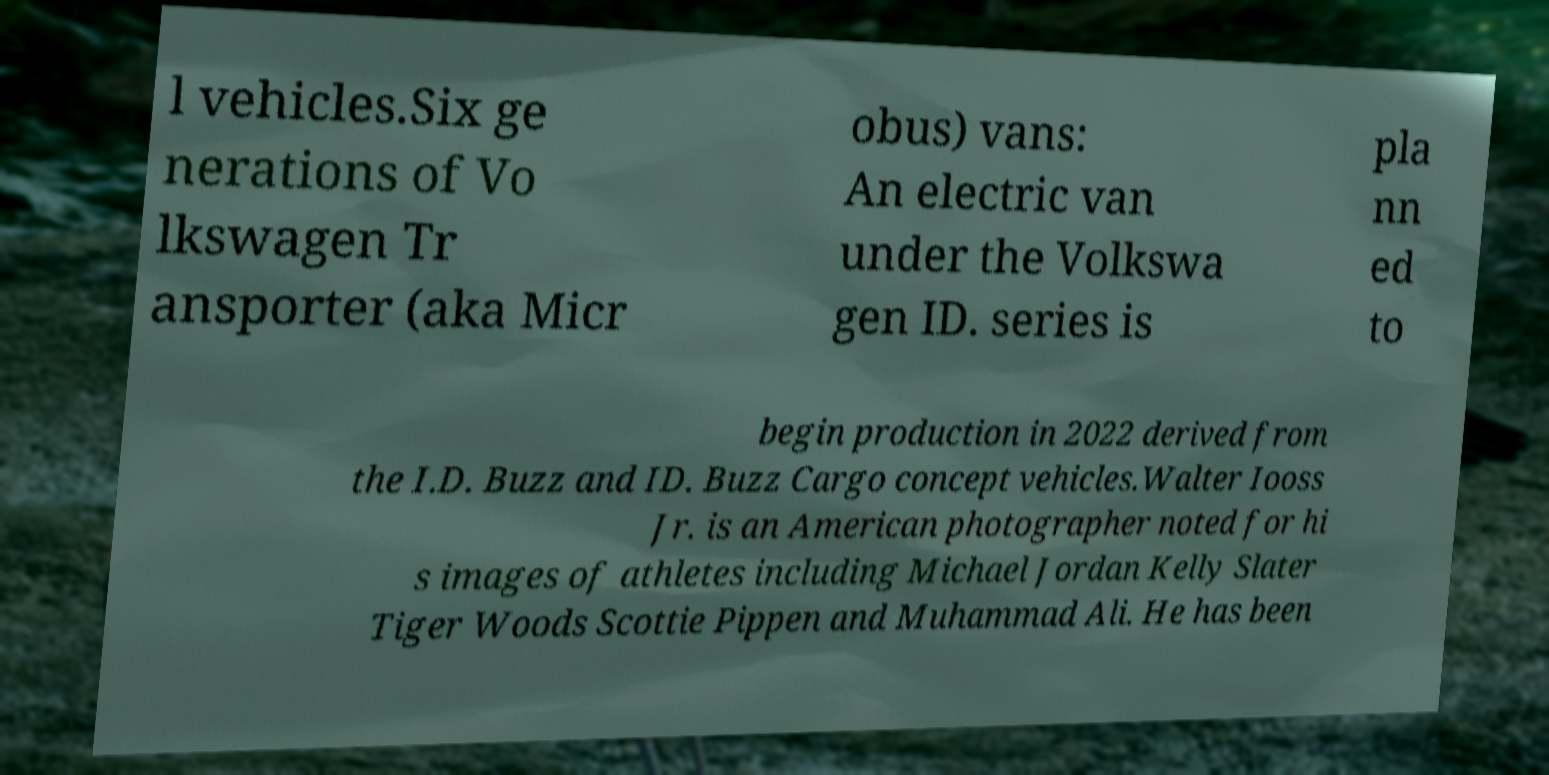There's text embedded in this image that I need extracted. Can you transcribe it verbatim? l vehicles.Six ge nerations of Vo lkswagen Tr ansporter (aka Micr obus) vans: An electric van under the Volkswa gen ID. series is pla nn ed to begin production in 2022 derived from the I.D. Buzz and ID. Buzz Cargo concept vehicles.Walter Iooss Jr. is an American photographer noted for hi s images of athletes including Michael Jordan Kelly Slater Tiger Woods Scottie Pippen and Muhammad Ali. He has been 